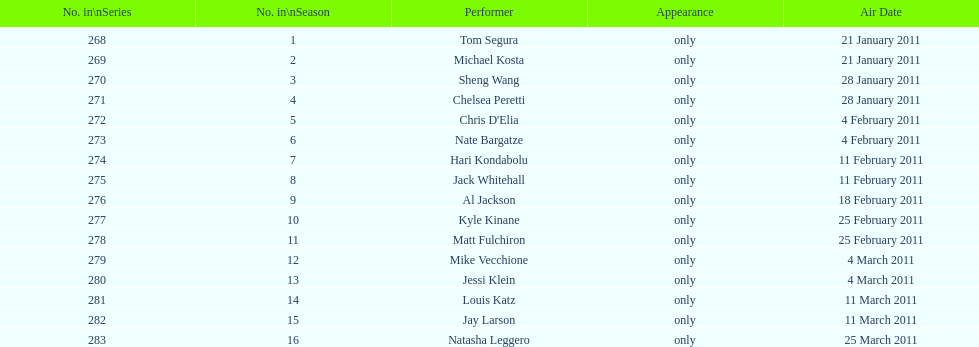How many weeks did season 15 of comedy central presents span? 9. 